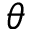Convert formula to latex. <formula><loc_0><loc_0><loc_500><loc_500>\theta</formula> 